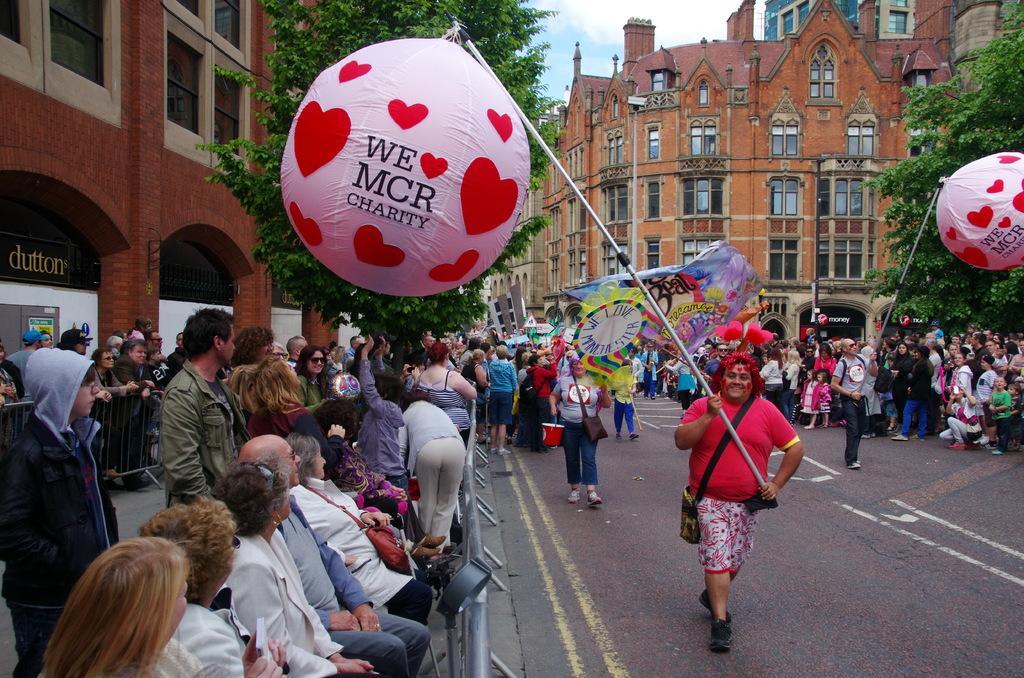Please provide a concise description of this image. In this image, we can see a group of people. Here we can see few people are holding some objects. Here we can see barricades, balloons, trees, buildings, walls, few things, glass objects and sky. Here we can see few people are smiling. 